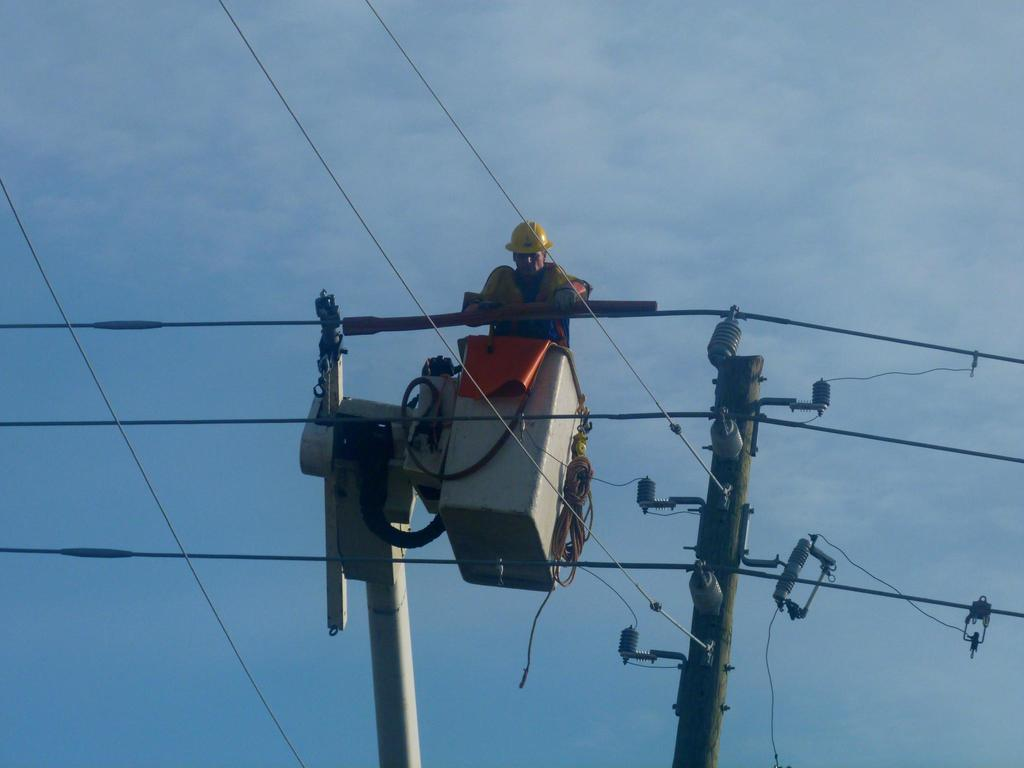What is located in the foreground of the image? There is a pole and cables in the foreground of the image. Can you describe the activity taking place in the foreground? It appears that there is a man in a crane basket in the foreground of the image. What can be seen in the background of the image? The sky and clouds are visible in the background of the image. What type of trousers is the man in the crane basket wearing in the image? There is no information about the man's trousers in the image, so we cannot determine what type he is wearing. What direction is the man in the crane basket facing in the image? The image does not provide information about the direction the man is facing, so we cannot determine his orientation. 